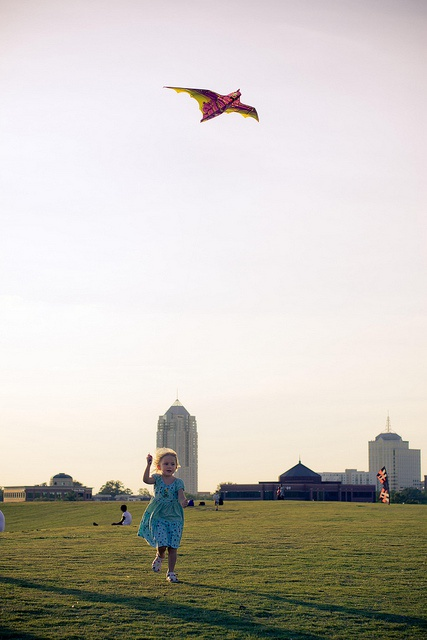Describe the objects in this image and their specific colors. I can see people in lightgray, blue, gray, and black tones, kite in lightgray, purple, and olive tones, people in lightgray, black, gray, and olive tones, people in lightgray, gray, black, blue, and navy tones, and people in lightgray, black, navy, gray, and blue tones in this image. 